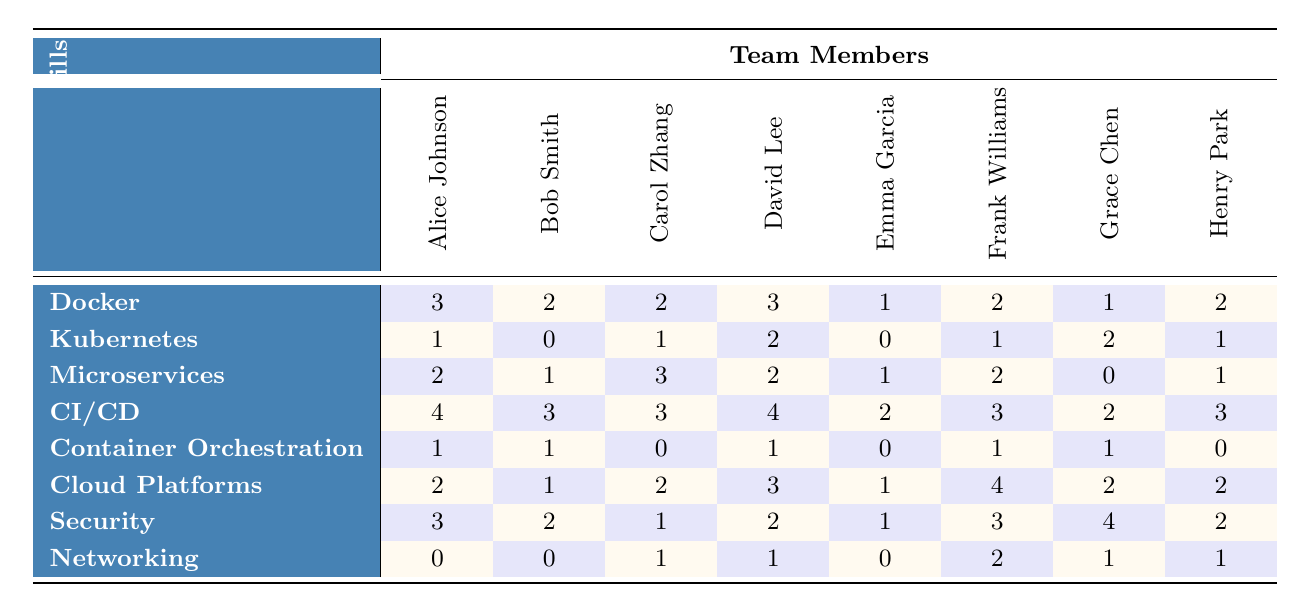What is the proficiency level of Alice Johnson in Docker? Alice Johnson has a proficiency level of 3 in Docker as indicated by the table.
Answer: 3 What is the highest proficiency level for CI/CD among the team members? The highest proficiency level for CI/CD is 4, as seen in the row for CI/CD, where David Lee achieved this level.
Answer: 4 Which skill has the lowest average proficiency across all team members? To find the skill with the lowest average proficiency, we calculate the average for each skill. The average for Container Orchestration is (1 + 1 + 0 + 1 + 0 + 1 + 1 + 0) / 8 = 0.625, which is the lowest compared to other skills.
Answer: Container Orchestration Is there any team member who has a proficiency level of 0 in Microservices? Yes, according to the table, Emma Garcia has a proficiency level of 0 in Microservices.
Answer: Yes What is the average proficiency level of the team in Kubernetes? The proficiency levels for Kubernetes are 1, 0, 1, 2, 0, 1, 2, 1. Adding these values gives 1 + 0 + 1 + 2 + 0 + 1 + 2 + 1 = 8. Since there are 8 team members, the average proficiency is 8/8 = 1.
Answer: 1 How many team members have a proficiency level of 2 or higher in Cloud Platforms? The proficiency levels for Cloud Platforms are 2, 1, 2, 3, 1, 4, 2, 2. The members with levels of 2 or higher are Alice Johnson (2), Carol Zhang (2), David Lee (3), Frank Williams (4), Grace Chen (2), and Henry Park (2), totaling 6 team members.
Answer: 6 Which skill has the highest proficiency level among the team members, and who has it? The highest proficiency level is 4 for CI/CD, which is achieved by David Lee. Thus, CI/CD has the highest proficiency level with David Lee being the skilled member.
Answer: CI/CD by David Lee Are there any team members that scored the same proficiency level in Security? Yes, Alice Johnson and Frank Williams both scored a proficiency level of 3 in Security, as indicated in the table.
Answer: Yes What is the overall average proficiency level for the team in all skills? The total proficiency counts for all skills sum up to: (3+2+2+3+1+2+1+2) + (1+0+1+2+0+1+2+1) + (2+1+3+2+1+2+0+1) + (4+3+3+4+2+3+2+3) + (1+1+0+1+0+1+1+0) + (2+1+2+3+1+4+2+2) + (3+2+1+2+1+3+4+2) + (0+0+1+1+0+2+1+1) = 43. Since there are 8 skills and 8 team members, the overall average is 43/(8*8) = 43/64 ≈ 0.67.
Answer: 0.67 Which team member has the highest proficiency level in Networking? The proficiency levels for Networking are 0, 0, 1, 1, 0, 2, 1, 1. Frank Williams has the highest proficiency level of 2 in Networking.
Answer: Frank Williams 